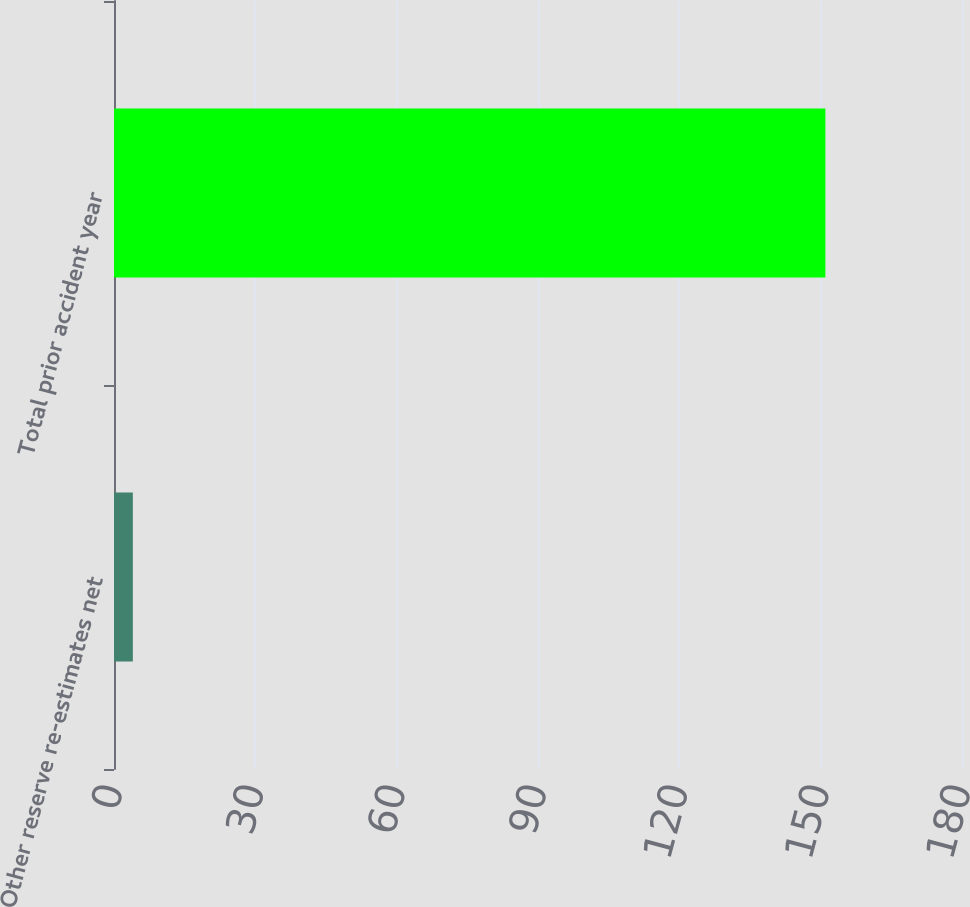<chart> <loc_0><loc_0><loc_500><loc_500><bar_chart><fcel>Other reserve re-estimates net<fcel>Total prior accident year<nl><fcel>4<fcel>151<nl></chart> 